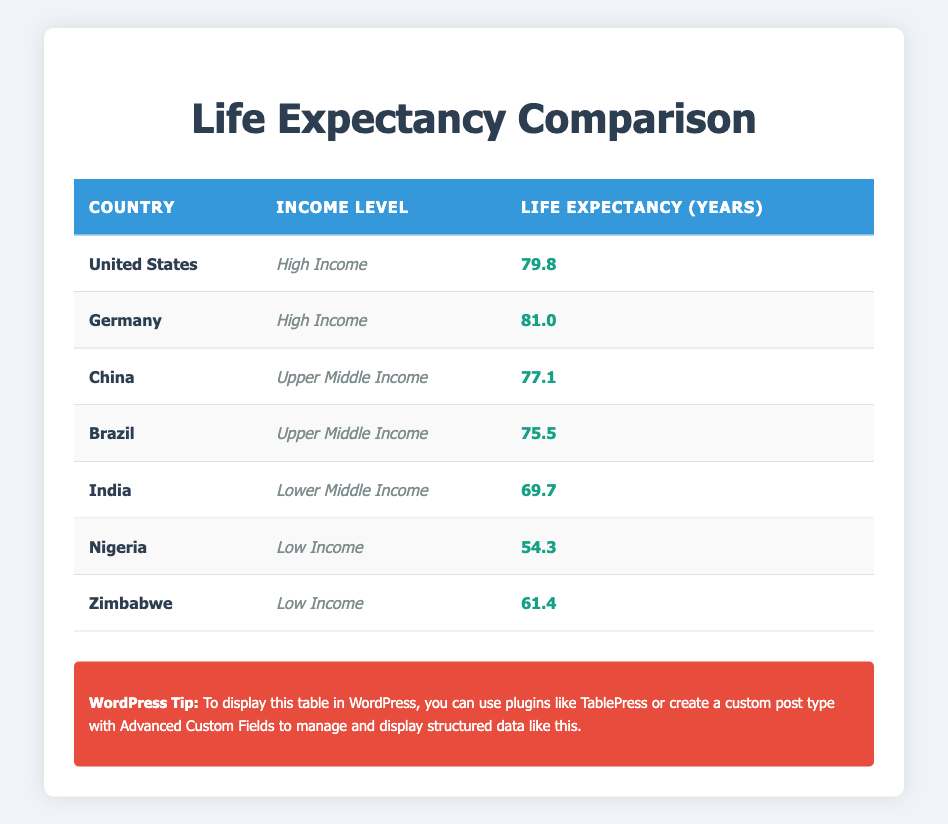What is the life expectancy in the United States? The life expectancy for the United States is listed in the table. By locating the row for the United States, we find the life expectancy value is 79.8 years.
Answer: 79.8 years Which country has the highest life expectancy among the high-income group? The table provides life expectancy values for countries categorized under high income. By examining the life expectancy values for the United States (79.8 years) and Germany (81.0 years), we see that Germany has the highest value of 81.0 years.
Answer: Germany What is the life expectancy difference between Brazil and India? We need to find the life expectancy for both Brazil (75.5 years) and India (69.7 years). The difference is calculated by subtracting India's life expectancy from Brazil's: 75.5 - 69.7 = 5.8 years.
Answer: 5.8 years Is China's life expectancy higher than that of Nigeria? We can check the life expectancy values for China (77.1 years) and Nigeria (54.3 years). Comparing these two values, China's life expectancy of 77.1 years is indeed higher than Nigeria's 54.3 years. Hence, the answer is true.
Answer: Yes What is the average life expectancy of the low-income countries listed in the table? The table shows life expectancy for two low-income countries: Nigeria (54.3 years) and Zimbabwe (61.4 years). To find the average, we sum the two life expectancies (54.3 + 61.4 = 115.7) and then divide by the number of countries (2): 115.7 / 2 = 57.85 years.
Answer: 57.85 years Which income level has the lowest life expectancy indicated in the table? By examining the table, we see Nigeria at 54.3 years and Zimbabwe at 61.4 years for the low-income level, and these values are lower than all other income levels. Therefore, low income has the lowest life expectancy.
Answer: Low Income How many countries in the table have a life expectancy of 75 years or more? We check the life expectancy values listed: United States (79.8), Germany (81.0), and China (77.1), indicating the group of countries with 75 years or more. This totals to three countries: the United States, Germany, and China.
Answer: Three countries What is the median life expectancy of the countries listed in the table? To find the median, we first need to arrange all life expectancy values in ascending order: 54.3, 61.4, 69.7, 75.5, 77.1, 79.8, 81.0. With seven data points, the median is the middle value, which is the fourth data point: 75.5 years.
Answer: 75.5 years 